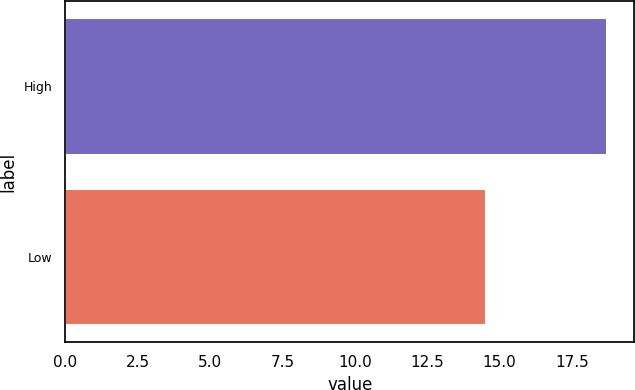<chart> <loc_0><loc_0><loc_500><loc_500><bar_chart><fcel>High<fcel>Low<nl><fcel>18.72<fcel>14.54<nl></chart> 